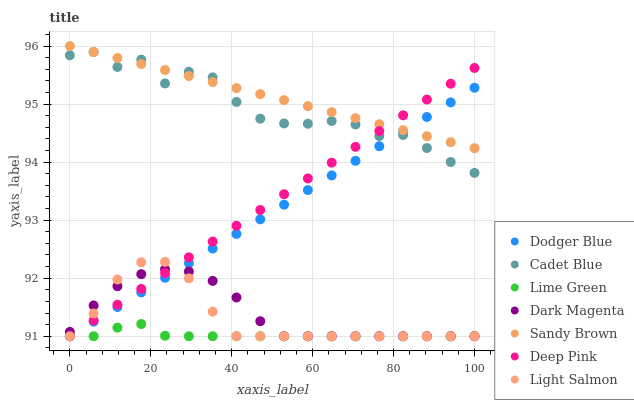Does Lime Green have the minimum area under the curve?
Answer yes or no. Yes. Does Sandy Brown have the maximum area under the curve?
Answer yes or no. Yes. Does Cadet Blue have the minimum area under the curve?
Answer yes or no. No. Does Cadet Blue have the maximum area under the curve?
Answer yes or no. No. Is Sandy Brown the smoothest?
Answer yes or no. Yes. Is Cadet Blue the roughest?
Answer yes or no. Yes. Is Dark Magenta the smoothest?
Answer yes or no. No. Is Dark Magenta the roughest?
Answer yes or no. No. Does Light Salmon have the lowest value?
Answer yes or no. Yes. Does Cadet Blue have the lowest value?
Answer yes or no. No. Does Sandy Brown have the highest value?
Answer yes or no. Yes. Does Cadet Blue have the highest value?
Answer yes or no. No. Is Light Salmon less than Sandy Brown?
Answer yes or no. Yes. Is Sandy Brown greater than Light Salmon?
Answer yes or no. Yes. Does Dodger Blue intersect Light Salmon?
Answer yes or no. Yes. Is Dodger Blue less than Light Salmon?
Answer yes or no. No. Is Dodger Blue greater than Light Salmon?
Answer yes or no. No. Does Light Salmon intersect Sandy Brown?
Answer yes or no. No. 